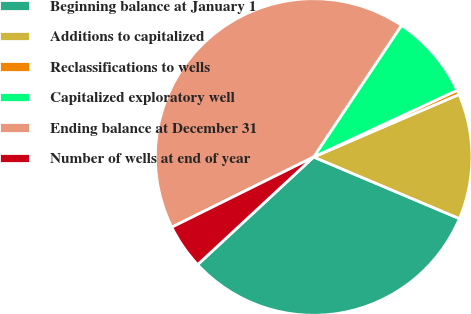<chart> <loc_0><loc_0><loc_500><loc_500><pie_chart><fcel>Beginning balance at January 1<fcel>Additions to capitalized<fcel>Reclassifications to wells<fcel>Capitalized exploratory well<fcel>Ending balance at December 31<fcel>Number of wells at end of year<nl><fcel>31.73%<fcel>12.83%<fcel>0.46%<fcel>8.71%<fcel>41.68%<fcel>4.59%<nl></chart> 